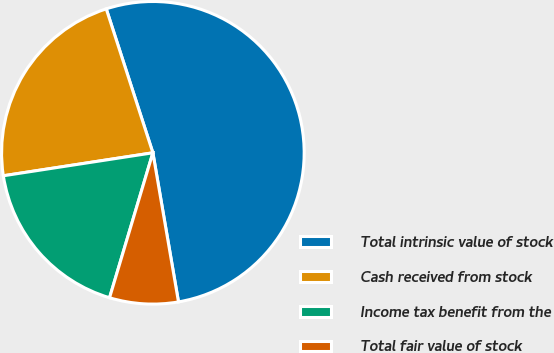Convert chart to OTSL. <chart><loc_0><loc_0><loc_500><loc_500><pie_chart><fcel>Total intrinsic value of stock<fcel>Cash received from stock<fcel>Income tax benefit from the<fcel>Total fair value of stock<nl><fcel>52.28%<fcel>22.44%<fcel>17.95%<fcel>7.33%<nl></chart> 